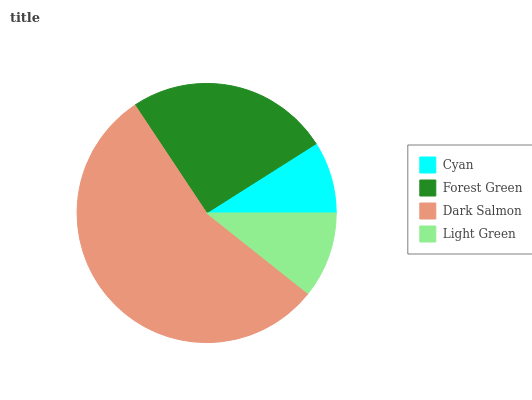Is Cyan the minimum?
Answer yes or no. Yes. Is Dark Salmon the maximum?
Answer yes or no. Yes. Is Forest Green the minimum?
Answer yes or no. No. Is Forest Green the maximum?
Answer yes or no. No. Is Forest Green greater than Cyan?
Answer yes or no. Yes. Is Cyan less than Forest Green?
Answer yes or no. Yes. Is Cyan greater than Forest Green?
Answer yes or no. No. Is Forest Green less than Cyan?
Answer yes or no. No. Is Forest Green the high median?
Answer yes or no. Yes. Is Light Green the low median?
Answer yes or no. Yes. Is Dark Salmon the high median?
Answer yes or no. No. Is Forest Green the low median?
Answer yes or no. No. 